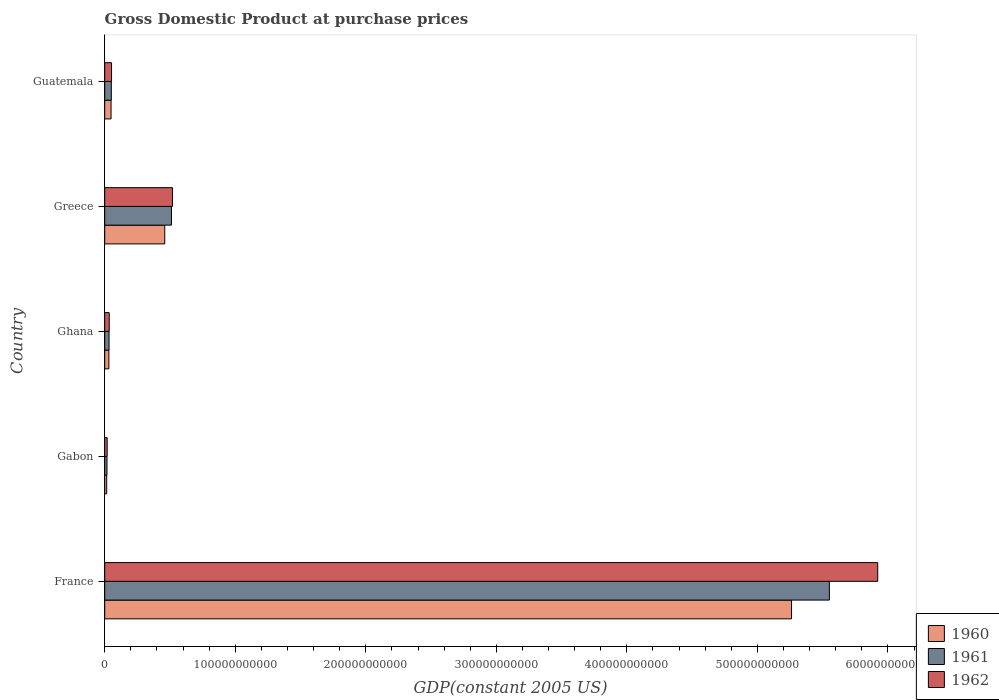How many different coloured bars are there?
Provide a short and direct response. 3. How many groups of bars are there?
Make the answer very short. 5. How many bars are there on the 4th tick from the top?
Your answer should be compact. 3. What is the label of the 1st group of bars from the top?
Give a very brief answer. Guatemala. What is the GDP at purchase prices in 1962 in Guatemala?
Your answer should be very brief. 5.23e+09. Across all countries, what is the maximum GDP at purchase prices in 1960?
Your answer should be compact. 5.26e+11. Across all countries, what is the minimum GDP at purchase prices in 1961?
Provide a succinct answer. 1.74e+09. In which country was the GDP at purchase prices in 1962 maximum?
Your answer should be very brief. France. In which country was the GDP at purchase prices in 1960 minimum?
Provide a short and direct response. Gabon. What is the total GDP at purchase prices in 1962 in the graph?
Offer a terse response. 6.55e+11. What is the difference between the GDP at purchase prices in 1961 in France and that in Gabon?
Your answer should be very brief. 5.53e+11. What is the difference between the GDP at purchase prices in 1962 in Greece and the GDP at purchase prices in 1961 in France?
Ensure brevity in your answer.  -5.03e+11. What is the average GDP at purchase prices in 1962 per country?
Make the answer very short. 1.31e+11. What is the difference between the GDP at purchase prices in 1962 and GDP at purchase prices in 1960 in Gabon?
Provide a short and direct response. 3.54e+08. What is the ratio of the GDP at purchase prices in 1962 in Gabon to that in Greece?
Your answer should be very brief. 0.04. Is the GDP at purchase prices in 1962 in France less than that in Guatemala?
Give a very brief answer. No. Is the difference between the GDP at purchase prices in 1962 in Gabon and Ghana greater than the difference between the GDP at purchase prices in 1960 in Gabon and Ghana?
Offer a very short reply. Yes. What is the difference between the highest and the second highest GDP at purchase prices in 1962?
Make the answer very short. 5.40e+11. What is the difference between the highest and the lowest GDP at purchase prices in 1960?
Make the answer very short. 5.25e+11. What does the 3rd bar from the bottom in France represents?
Your answer should be compact. 1962. Is it the case that in every country, the sum of the GDP at purchase prices in 1961 and GDP at purchase prices in 1962 is greater than the GDP at purchase prices in 1960?
Offer a very short reply. Yes. How many bars are there?
Your answer should be very brief. 15. What is the difference between two consecutive major ticks on the X-axis?
Ensure brevity in your answer.  1.00e+11. Are the values on the major ticks of X-axis written in scientific E-notation?
Your response must be concise. No. Does the graph contain any zero values?
Provide a succinct answer. No. Where does the legend appear in the graph?
Keep it short and to the point. Bottom right. What is the title of the graph?
Your response must be concise. Gross Domestic Product at purchase prices. Does "2008" appear as one of the legend labels in the graph?
Offer a terse response. No. What is the label or title of the X-axis?
Provide a short and direct response. GDP(constant 2005 US). What is the GDP(constant 2005 US) of 1960 in France?
Offer a very short reply. 5.26e+11. What is the GDP(constant 2005 US) in 1961 in France?
Give a very brief answer. 5.55e+11. What is the GDP(constant 2005 US) in 1962 in France?
Ensure brevity in your answer.  5.92e+11. What is the GDP(constant 2005 US) in 1960 in Gabon?
Offer a very short reply. 1.52e+09. What is the GDP(constant 2005 US) in 1961 in Gabon?
Ensure brevity in your answer.  1.74e+09. What is the GDP(constant 2005 US) in 1962 in Gabon?
Offer a terse response. 1.87e+09. What is the GDP(constant 2005 US) of 1960 in Ghana?
Give a very brief answer. 3.20e+09. What is the GDP(constant 2005 US) of 1961 in Ghana?
Provide a short and direct response. 3.31e+09. What is the GDP(constant 2005 US) of 1962 in Ghana?
Ensure brevity in your answer.  3.45e+09. What is the GDP(constant 2005 US) of 1960 in Greece?
Offer a terse response. 4.60e+1. What is the GDP(constant 2005 US) of 1961 in Greece?
Make the answer very short. 5.11e+1. What is the GDP(constant 2005 US) of 1962 in Greece?
Ensure brevity in your answer.  5.19e+1. What is the GDP(constant 2005 US) in 1960 in Guatemala?
Your response must be concise. 4.85e+09. What is the GDP(constant 2005 US) of 1961 in Guatemala?
Your answer should be compact. 5.06e+09. What is the GDP(constant 2005 US) in 1962 in Guatemala?
Ensure brevity in your answer.  5.23e+09. Across all countries, what is the maximum GDP(constant 2005 US) of 1960?
Your answer should be very brief. 5.26e+11. Across all countries, what is the maximum GDP(constant 2005 US) in 1961?
Provide a succinct answer. 5.55e+11. Across all countries, what is the maximum GDP(constant 2005 US) in 1962?
Provide a short and direct response. 5.92e+11. Across all countries, what is the minimum GDP(constant 2005 US) of 1960?
Ensure brevity in your answer.  1.52e+09. Across all countries, what is the minimum GDP(constant 2005 US) of 1961?
Provide a short and direct response. 1.74e+09. Across all countries, what is the minimum GDP(constant 2005 US) of 1962?
Provide a short and direct response. 1.87e+09. What is the total GDP(constant 2005 US) in 1960 in the graph?
Provide a short and direct response. 5.82e+11. What is the total GDP(constant 2005 US) in 1961 in the graph?
Your answer should be very brief. 6.16e+11. What is the total GDP(constant 2005 US) of 1962 in the graph?
Provide a succinct answer. 6.55e+11. What is the difference between the GDP(constant 2005 US) of 1960 in France and that in Gabon?
Make the answer very short. 5.25e+11. What is the difference between the GDP(constant 2005 US) in 1961 in France and that in Gabon?
Your answer should be compact. 5.53e+11. What is the difference between the GDP(constant 2005 US) in 1962 in France and that in Gabon?
Offer a terse response. 5.90e+11. What is the difference between the GDP(constant 2005 US) of 1960 in France and that in Ghana?
Your answer should be compact. 5.23e+11. What is the difference between the GDP(constant 2005 US) of 1961 in France and that in Ghana?
Offer a very short reply. 5.52e+11. What is the difference between the GDP(constant 2005 US) in 1962 in France and that in Ghana?
Offer a very short reply. 5.89e+11. What is the difference between the GDP(constant 2005 US) of 1960 in France and that in Greece?
Make the answer very short. 4.80e+11. What is the difference between the GDP(constant 2005 US) of 1961 in France and that in Greece?
Ensure brevity in your answer.  5.04e+11. What is the difference between the GDP(constant 2005 US) of 1962 in France and that in Greece?
Provide a short and direct response. 5.40e+11. What is the difference between the GDP(constant 2005 US) in 1960 in France and that in Guatemala?
Provide a succinct answer. 5.21e+11. What is the difference between the GDP(constant 2005 US) in 1961 in France and that in Guatemala?
Your answer should be very brief. 5.50e+11. What is the difference between the GDP(constant 2005 US) in 1962 in France and that in Guatemala?
Your response must be concise. 5.87e+11. What is the difference between the GDP(constant 2005 US) in 1960 in Gabon and that in Ghana?
Provide a succinct answer. -1.68e+09. What is the difference between the GDP(constant 2005 US) in 1961 in Gabon and that in Ghana?
Provide a short and direct response. -1.57e+09. What is the difference between the GDP(constant 2005 US) in 1962 in Gabon and that in Ghana?
Make the answer very short. -1.58e+09. What is the difference between the GDP(constant 2005 US) of 1960 in Gabon and that in Greece?
Provide a short and direct response. -4.45e+1. What is the difference between the GDP(constant 2005 US) in 1961 in Gabon and that in Greece?
Your response must be concise. -4.94e+1. What is the difference between the GDP(constant 2005 US) of 1962 in Gabon and that in Greece?
Ensure brevity in your answer.  -5.00e+1. What is the difference between the GDP(constant 2005 US) in 1960 in Gabon and that in Guatemala?
Make the answer very short. -3.33e+09. What is the difference between the GDP(constant 2005 US) in 1961 in Gabon and that in Guatemala?
Ensure brevity in your answer.  -3.31e+09. What is the difference between the GDP(constant 2005 US) in 1962 in Gabon and that in Guatemala?
Keep it short and to the point. -3.36e+09. What is the difference between the GDP(constant 2005 US) of 1960 in Ghana and that in Greece?
Your answer should be compact. -4.28e+1. What is the difference between the GDP(constant 2005 US) in 1961 in Ghana and that in Greece?
Offer a terse response. -4.78e+1. What is the difference between the GDP(constant 2005 US) in 1962 in Ghana and that in Greece?
Offer a terse response. -4.85e+1. What is the difference between the GDP(constant 2005 US) in 1960 in Ghana and that in Guatemala?
Offer a terse response. -1.64e+09. What is the difference between the GDP(constant 2005 US) of 1961 in Ghana and that in Guatemala?
Ensure brevity in your answer.  -1.74e+09. What is the difference between the GDP(constant 2005 US) in 1962 in Ghana and that in Guatemala?
Your response must be concise. -1.78e+09. What is the difference between the GDP(constant 2005 US) of 1960 in Greece and that in Guatemala?
Offer a terse response. 4.11e+1. What is the difference between the GDP(constant 2005 US) of 1961 in Greece and that in Guatemala?
Keep it short and to the point. 4.61e+1. What is the difference between the GDP(constant 2005 US) in 1962 in Greece and that in Guatemala?
Offer a very short reply. 4.67e+1. What is the difference between the GDP(constant 2005 US) of 1960 in France and the GDP(constant 2005 US) of 1961 in Gabon?
Offer a very short reply. 5.24e+11. What is the difference between the GDP(constant 2005 US) in 1960 in France and the GDP(constant 2005 US) in 1962 in Gabon?
Provide a succinct answer. 5.24e+11. What is the difference between the GDP(constant 2005 US) in 1961 in France and the GDP(constant 2005 US) in 1962 in Gabon?
Your response must be concise. 5.53e+11. What is the difference between the GDP(constant 2005 US) of 1960 in France and the GDP(constant 2005 US) of 1961 in Ghana?
Provide a succinct answer. 5.23e+11. What is the difference between the GDP(constant 2005 US) of 1960 in France and the GDP(constant 2005 US) of 1962 in Ghana?
Your answer should be compact. 5.23e+11. What is the difference between the GDP(constant 2005 US) in 1961 in France and the GDP(constant 2005 US) in 1962 in Ghana?
Your answer should be very brief. 5.52e+11. What is the difference between the GDP(constant 2005 US) in 1960 in France and the GDP(constant 2005 US) in 1961 in Greece?
Keep it short and to the point. 4.75e+11. What is the difference between the GDP(constant 2005 US) of 1960 in France and the GDP(constant 2005 US) of 1962 in Greece?
Your answer should be very brief. 4.74e+11. What is the difference between the GDP(constant 2005 US) of 1961 in France and the GDP(constant 2005 US) of 1962 in Greece?
Offer a very short reply. 5.03e+11. What is the difference between the GDP(constant 2005 US) of 1960 in France and the GDP(constant 2005 US) of 1961 in Guatemala?
Offer a terse response. 5.21e+11. What is the difference between the GDP(constant 2005 US) in 1960 in France and the GDP(constant 2005 US) in 1962 in Guatemala?
Give a very brief answer. 5.21e+11. What is the difference between the GDP(constant 2005 US) of 1961 in France and the GDP(constant 2005 US) of 1962 in Guatemala?
Give a very brief answer. 5.50e+11. What is the difference between the GDP(constant 2005 US) in 1960 in Gabon and the GDP(constant 2005 US) in 1961 in Ghana?
Your answer should be compact. -1.79e+09. What is the difference between the GDP(constant 2005 US) of 1960 in Gabon and the GDP(constant 2005 US) of 1962 in Ghana?
Provide a short and direct response. -1.93e+09. What is the difference between the GDP(constant 2005 US) of 1961 in Gabon and the GDP(constant 2005 US) of 1962 in Ghana?
Provide a succinct answer. -1.71e+09. What is the difference between the GDP(constant 2005 US) of 1960 in Gabon and the GDP(constant 2005 US) of 1961 in Greece?
Provide a succinct answer. -4.96e+1. What is the difference between the GDP(constant 2005 US) in 1960 in Gabon and the GDP(constant 2005 US) in 1962 in Greece?
Provide a short and direct response. -5.04e+1. What is the difference between the GDP(constant 2005 US) in 1961 in Gabon and the GDP(constant 2005 US) in 1962 in Greece?
Make the answer very short. -5.02e+1. What is the difference between the GDP(constant 2005 US) in 1960 in Gabon and the GDP(constant 2005 US) in 1961 in Guatemala?
Keep it short and to the point. -3.54e+09. What is the difference between the GDP(constant 2005 US) of 1960 in Gabon and the GDP(constant 2005 US) of 1962 in Guatemala?
Give a very brief answer. -3.72e+09. What is the difference between the GDP(constant 2005 US) of 1961 in Gabon and the GDP(constant 2005 US) of 1962 in Guatemala?
Your answer should be compact. -3.49e+09. What is the difference between the GDP(constant 2005 US) in 1960 in Ghana and the GDP(constant 2005 US) in 1961 in Greece?
Your answer should be very brief. -4.79e+1. What is the difference between the GDP(constant 2005 US) of 1960 in Ghana and the GDP(constant 2005 US) of 1962 in Greece?
Provide a succinct answer. -4.87e+1. What is the difference between the GDP(constant 2005 US) of 1961 in Ghana and the GDP(constant 2005 US) of 1962 in Greece?
Give a very brief answer. -4.86e+1. What is the difference between the GDP(constant 2005 US) of 1960 in Ghana and the GDP(constant 2005 US) of 1961 in Guatemala?
Ensure brevity in your answer.  -1.85e+09. What is the difference between the GDP(constant 2005 US) of 1960 in Ghana and the GDP(constant 2005 US) of 1962 in Guatemala?
Provide a succinct answer. -2.03e+09. What is the difference between the GDP(constant 2005 US) of 1961 in Ghana and the GDP(constant 2005 US) of 1962 in Guatemala?
Offer a terse response. -1.92e+09. What is the difference between the GDP(constant 2005 US) in 1960 in Greece and the GDP(constant 2005 US) in 1961 in Guatemala?
Provide a succinct answer. 4.09e+1. What is the difference between the GDP(constant 2005 US) in 1960 in Greece and the GDP(constant 2005 US) in 1962 in Guatemala?
Keep it short and to the point. 4.08e+1. What is the difference between the GDP(constant 2005 US) of 1961 in Greece and the GDP(constant 2005 US) of 1962 in Guatemala?
Ensure brevity in your answer.  4.59e+1. What is the average GDP(constant 2005 US) in 1960 per country?
Your answer should be very brief. 1.16e+11. What is the average GDP(constant 2005 US) of 1961 per country?
Make the answer very short. 1.23e+11. What is the average GDP(constant 2005 US) in 1962 per country?
Your answer should be very brief. 1.31e+11. What is the difference between the GDP(constant 2005 US) in 1960 and GDP(constant 2005 US) in 1961 in France?
Ensure brevity in your answer.  -2.90e+1. What is the difference between the GDP(constant 2005 US) in 1960 and GDP(constant 2005 US) in 1962 in France?
Offer a terse response. -6.60e+1. What is the difference between the GDP(constant 2005 US) of 1961 and GDP(constant 2005 US) of 1962 in France?
Offer a very short reply. -3.70e+1. What is the difference between the GDP(constant 2005 US) of 1960 and GDP(constant 2005 US) of 1961 in Gabon?
Offer a very short reply. -2.24e+08. What is the difference between the GDP(constant 2005 US) of 1960 and GDP(constant 2005 US) of 1962 in Gabon?
Provide a short and direct response. -3.54e+08. What is the difference between the GDP(constant 2005 US) of 1961 and GDP(constant 2005 US) of 1962 in Gabon?
Offer a terse response. -1.30e+08. What is the difference between the GDP(constant 2005 US) in 1960 and GDP(constant 2005 US) in 1961 in Ghana?
Make the answer very short. -1.10e+08. What is the difference between the GDP(constant 2005 US) of 1960 and GDP(constant 2005 US) of 1962 in Ghana?
Your response must be concise. -2.46e+08. What is the difference between the GDP(constant 2005 US) in 1961 and GDP(constant 2005 US) in 1962 in Ghana?
Provide a succinct answer. -1.36e+08. What is the difference between the GDP(constant 2005 US) of 1960 and GDP(constant 2005 US) of 1961 in Greece?
Provide a succinct answer. -5.13e+09. What is the difference between the GDP(constant 2005 US) in 1960 and GDP(constant 2005 US) in 1962 in Greece?
Provide a short and direct response. -5.91e+09. What is the difference between the GDP(constant 2005 US) in 1961 and GDP(constant 2005 US) in 1962 in Greece?
Provide a short and direct response. -7.84e+08. What is the difference between the GDP(constant 2005 US) in 1960 and GDP(constant 2005 US) in 1961 in Guatemala?
Provide a succinct answer. -2.08e+08. What is the difference between the GDP(constant 2005 US) of 1960 and GDP(constant 2005 US) of 1962 in Guatemala?
Keep it short and to the point. -3.87e+08. What is the difference between the GDP(constant 2005 US) in 1961 and GDP(constant 2005 US) in 1962 in Guatemala?
Your answer should be compact. -1.79e+08. What is the ratio of the GDP(constant 2005 US) in 1960 in France to that in Gabon?
Your response must be concise. 346.25. What is the ratio of the GDP(constant 2005 US) of 1961 in France to that in Gabon?
Offer a very short reply. 318.31. What is the ratio of the GDP(constant 2005 US) in 1962 in France to that in Gabon?
Keep it short and to the point. 316. What is the ratio of the GDP(constant 2005 US) of 1960 in France to that in Ghana?
Your answer should be compact. 164.23. What is the ratio of the GDP(constant 2005 US) in 1961 in France to that in Ghana?
Offer a terse response. 167.52. What is the ratio of the GDP(constant 2005 US) of 1962 in France to that in Ghana?
Keep it short and to the point. 171.65. What is the ratio of the GDP(constant 2005 US) in 1960 in France to that in Greece?
Your answer should be compact. 11.44. What is the ratio of the GDP(constant 2005 US) in 1961 in France to that in Greece?
Make the answer very short. 10.86. What is the ratio of the GDP(constant 2005 US) of 1962 in France to that in Greece?
Offer a very short reply. 11.41. What is the ratio of the GDP(constant 2005 US) in 1960 in France to that in Guatemala?
Your response must be concise. 108.54. What is the ratio of the GDP(constant 2005 US) of 1961 in France to that in Guatemala?
Keep it short and to the point. 109.8. What is the ratio of the GDP(constant 2005 US) in 1962 in France to that in Guatemala?
Offer a very short reply. 113.12. What is the ratio of the GDP(constant 2005 US) in 1960 in Gabon to that in Ghana?
Offer a very short reply. 0.47. What is the ratio of the GDP(constant 2005 US) of 1961 in Gabon to that in Ghana?
Offer a terse response. 0.53. What is the ratio of the GDP(constant 2005 US) in 1962 in Gabon to that in Ghana?
Provide a short and direct response. 0.54. What is the ratio of the GDP(constant 2005 US) of 1960 in Gabon to that in Greece?
Make the answer very short. 0.03. What is the ratio of the GDP(constant 2005 US) in 1961 in Gabon to that in Greece?
Provide a succinct answer. 0.03. What is the ratio of the GDP(constant 2005 US) in 1962 in Gabon to that in Greece?
Provide a succinct answer. 0.04. What is the ratio of the GDP(constant 2005 US) in 1960 in Gabon to that in Guatemala?
Provide a succinct answer. 0.31. What is the ratio of the GDP(constant 2005 US) of 1961 in Gabon to that in Guatemala?
Your response must be concise. 0.34. What is the ratio of the GDP(constant 2005 US) of 1962 in Gabon to that in Guatemala?
Provide a succinct answer. 0.36. What is the ratio of the GDP(constant 2005 US) of 1960 in Ghana to that in Greece?
Your answer should be very brief. 0.07. What is the ratio of the GDP(constant 2005 US) in 1961 in Ghana to that in Greece?
Provide a succinct answer. 0.06. What is the ratio of the GDP(constant 2005 US) of 1962 in Ghana to that in Greece?
Your answer should be very brief. 0.07. What is the ratio of the GDP(constant 2005 US) in 1960 in Ghana to that in Guatemala?
Provide a short and direct response. 0.66. What is the ratio of the GDP(constant 2005 US) of 1961 in Ghana to that in Guatemala?
Provide a succinct answer. 0.66. What is the ratio of the GDP(constant 2005 US) of 1962 in Ghana to that in Guatemala?
Ensure brevity in your answer.  0.66. What is the ratio of the GDP(constant 2005 US) of 1960 in Greece to that in Guatemala?
Provide a succinct answer. 9.49. What is the ratio of the GDP(constant 2005 US) in 1961 in Greece to that in Guatemala?
Offer a terse response. 10.11. What is the ratio of the GDP(constant 2005 US) in 1962 in Greece to that in Guatemala?
Make the answer very short. 9.92. What is the difference between the highest and the second highest GDP(constant 2005 US) in 1960?
Offer a very short reply. 4.80e+11. What is the difference between the highest and the second highest GDP(constant 2005 US) in 1961?
Your response must be concise. 5.04e+11. What is the difference between the highest and the second highest GDP(constant 2005 US) in 1962?
Give a very brief answer. 5.40e+11. What is the difference between the highest and the lowest GDP(constant 2005 US) of 1960?
Your answer should be compact. 5.25e+11. What is the difference between the highest and the lowest GDP(constant 2005 US) of 1961?
Give a very brief answer. 5.53e+11. What is the difference between the highest and the lowest GDP(constant 2005 US) in 1962?
Ensure brevity in your answer.  5.90e+11. 